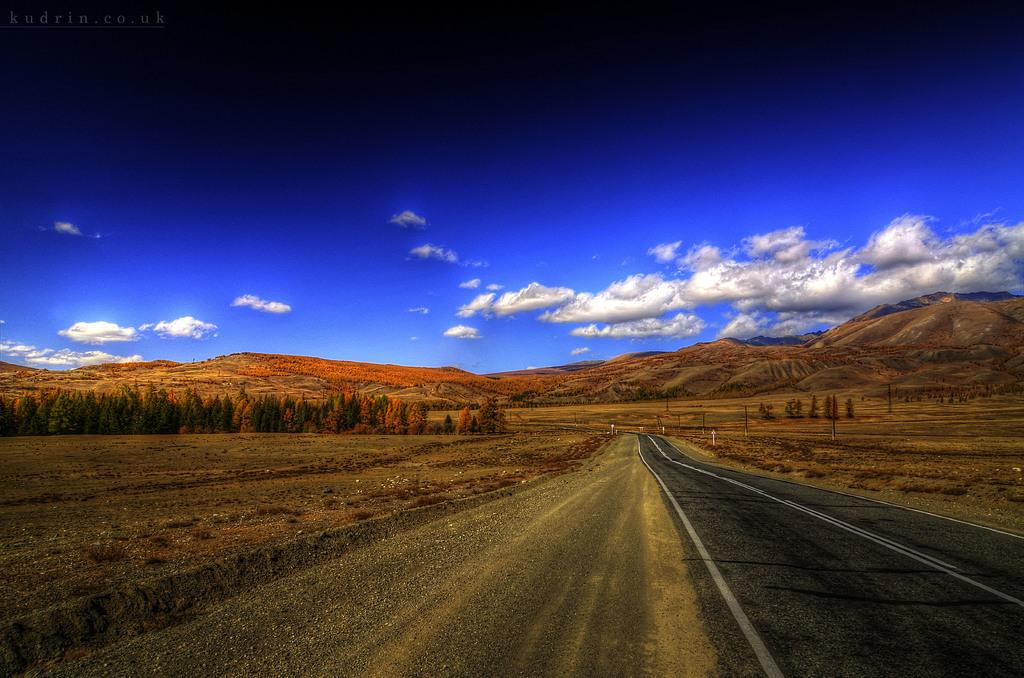What type of vegetation can be seen in the image? There are trees in the image. What type of man-made structure is visible in the image? There is a road in the image. What part of the natural environment is visible in the image? The sky is visible in the image. What type of voice can be heard coming from the trees in the image? There is no voice present in the image, as trees do not have the ability to produce or convey sound. 